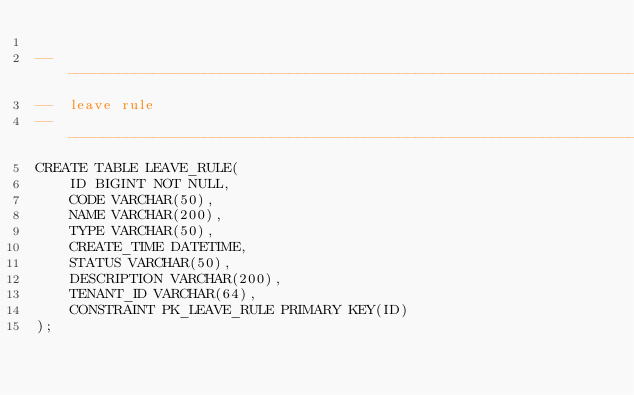<code> <loc_0><loc_0><loc_500><loc_500><_SQL_>
-------------------------------------------------------------------------------
--  leave rule
-------------------------------------------------------------------------------
CREATE TABLE LEAVE_RULE(
    ID BIGINT NOT NULL,
    CODE VARCHAR(50),
    NAME VARCHAR(200),
    TYPE VARCHAR(50),
    CREATE_TIME DATETIME,
    STATUS VARCHAR(50),
    DESCRIPTION VARCHAR(200),
    TENANT_ID VARCHAR(64),
    CONSTRAINT PK_LEAVE_RULE PRIMARY KEY(ID)
);

</code> 